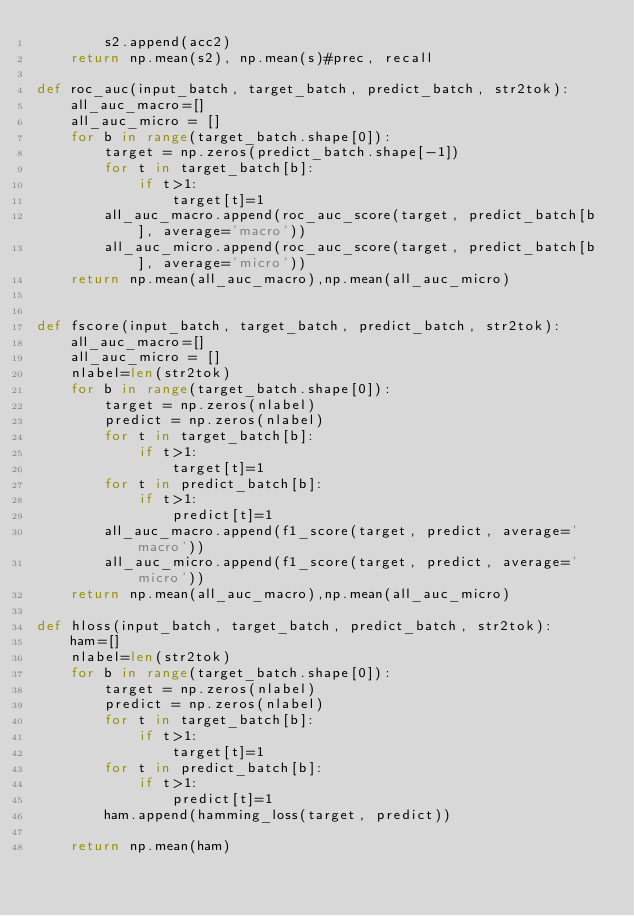<code> <loc_0><loc_0><loc_500><loc_500><_Python_>        s2.append(acc2)
    return np.mean(s2), np.mean(s)#prec, recall

def roc_auc(input_batch, target_batch, predict_batch, str2tok):
    all_auc_macro=[]
    all_auc_micro = []
    for b in range(target_batch.shape[0]):
        target = np.zeros(predict_batch.shape[-1])
        for t in target_batch[b]:
            if t>1:
                target[t]=1
        all_auc_macro.append(roc_auc_score(target, predict_batch[b], average='macro'))
        all_auc_micro.append(roc_auc_score(target, predict_batch[b], average='micro'))
    return np.mean(all_auc_macro),np.mean(all_auc_micro)


def fscore(input_batch, target_batch, predict_batch, str2tok):
    all_auc_macro=[]
    all_auc_micro = []
    nlabel=len(str2tok)
    for b in range(target_batch.shape[0]):
        target = np.zeros(nlabel)
        predict = np.zeros(nlabel)
        for t in target_batch[b]:
            if t>1:
                target[t]=1
        for t in predict_batch[b]:
            if t>1:
                predict[t]=1
        all_auc_macro.append(f1_score(target, predict, average='macro'))
        all_auc_micro.append(f1_score(target, predict, average='micro'))
    return np.mean(all_auc_macro),np.mean(all_auc_micro)

def hloss(input_batch, target_batch, predict_batch, str2tok):
    ham=[]
    nlabel=len(str2tok)
    for b in range(target_batch.shape[0]):
        target = np.zeros(nlabel)
        predict = np.zeros(nlabel)
        for t in target_batch[b]:
            if t>1:
                target[t]=1
        for t in predict_batch[b]:
            if t>1:
                predict[t]=1
        ham.append(hamming_loss(target, predict))

    return np.mean(ham)</code> 